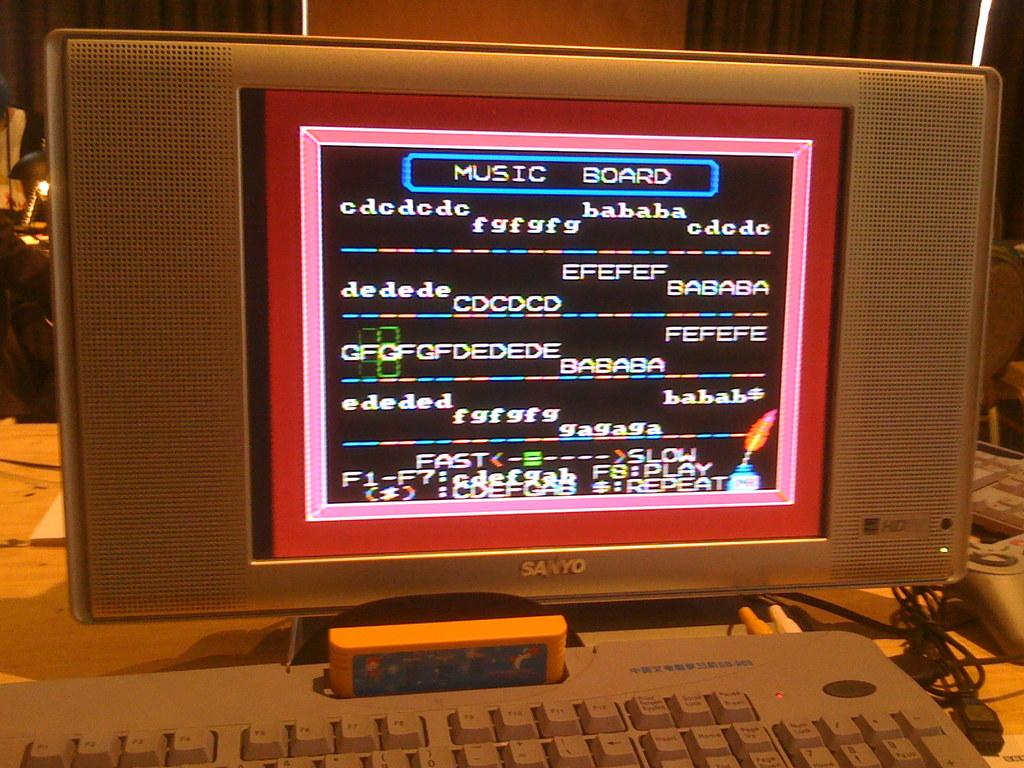<image>
Summarize the visual content of the image. Old Sanyo monitor with music board opened on it 